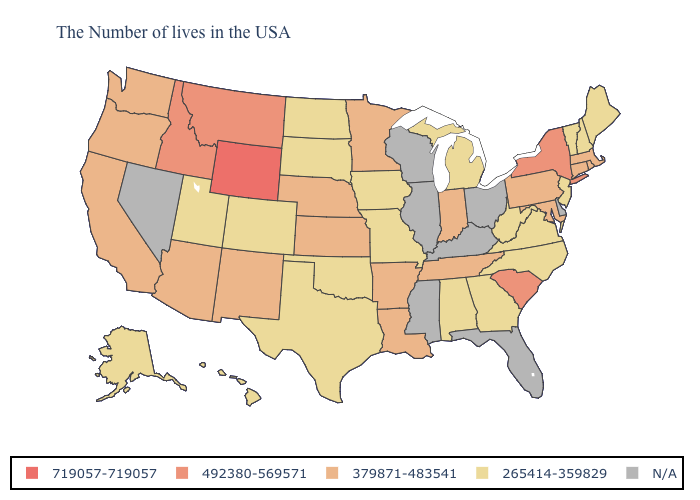Among the states that border Arkansas , which have the highest value?
Short answer required. Tennessee, Louisiana. Name the states that have a value in the range 379871-483541?
Write a very short answer. Massachusetts, Rhode Island, Connecticut, Maryland, Pennsylvania, Indiana, Tennessee, Louisiana, Arkansas, Minnesota, Kansas, Nebraska, New Mexico, Arizona, California, Washington, Oregon. What is the lowest value in the MidWest?
Answer briefly. 265414-359829. Name the states that have a value in the range N/A?
Short answer required. Delaware, Ohio, Florida, Kentucky, Wisconsin, Illinois, Mississippi, Nevada. What is the highest value in the USA?
Short answer required. 719057-719057. What is the value of Alabama?
Answer briefly. 265414-359829. Name the states that have a value in the range 379871-483541?
Answer briefly. Massachusetts, Rhode Island, Connecticut, Maryland, Pennsylvania, Indiana, Tennessee, Louisiana, Arkansas, Minnesota, Kansas, Nebraska, New Mexico, Arizona, California, Washington, Oregon. Does Wyoming have the highest value in the West?
Quick response, please. Yes. What is the highest value in the USA?
Give a very brief answer. 719057-719057. Does Massachusetts have the lowest value in the Northeast?
Keep it brief. No. What is the lowest value in the Northeast?
Write a very short answer. 265414-359829. What is the value of Texas?
Write a very short answer. 265414-359829. 